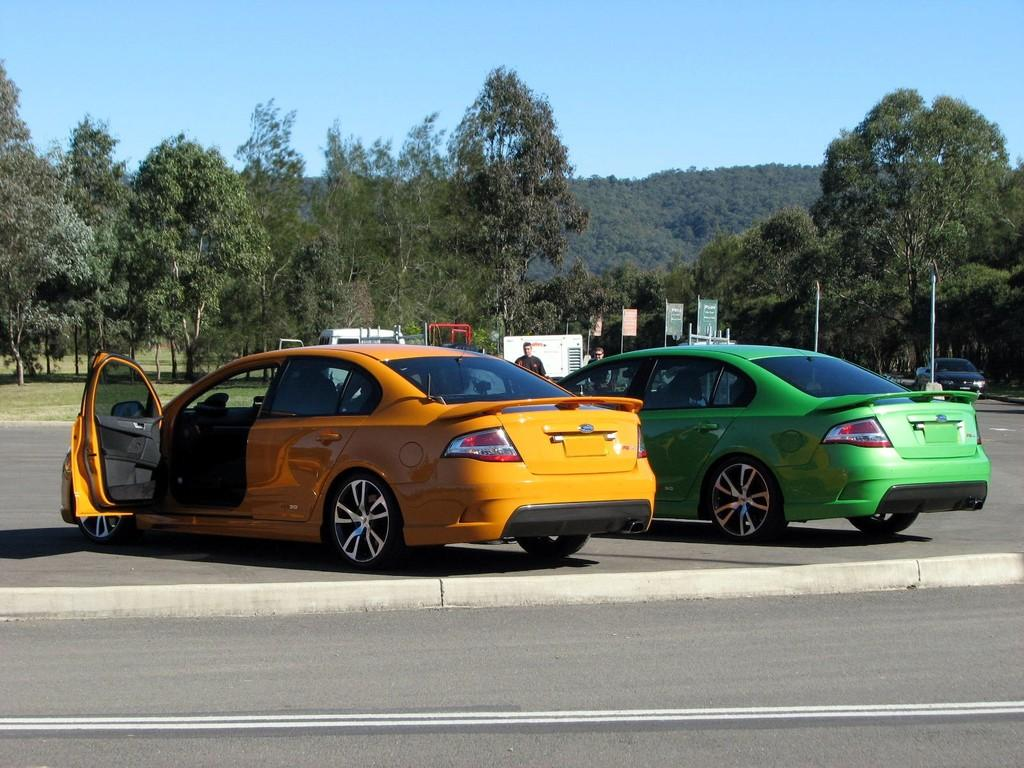What colors are the cars in the image? There is a green car and a yellow car in the image. What can be seen in the background of the image? There are green trees in the background of the image. What color is the sky in the image? The sky is blue in the image. What is the mouth of the green car saying in the image? Cars do not have mouths, so this question cannot be answered. 